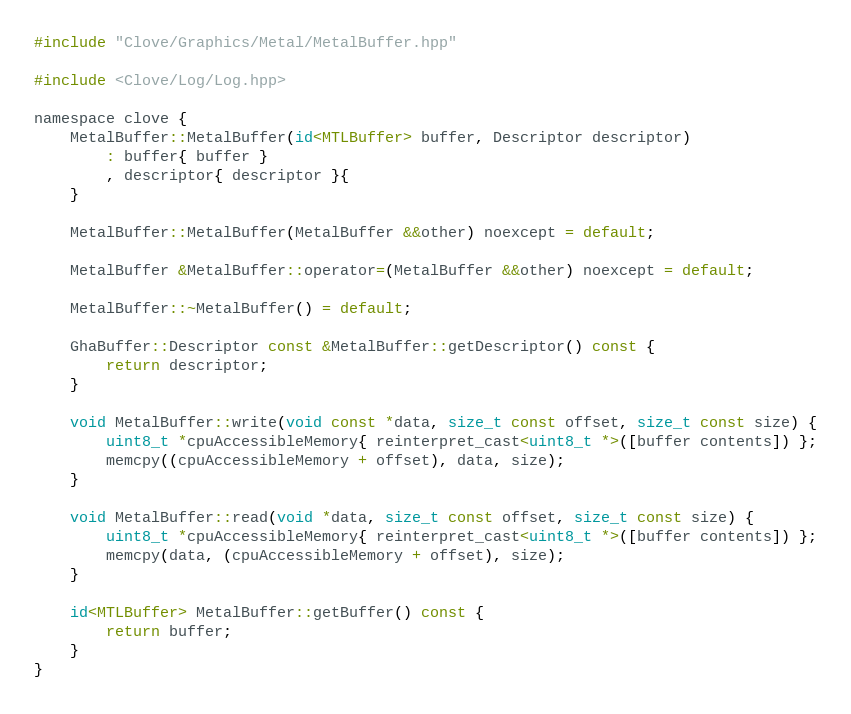<code> <loc_0><loc_0><loc_500><loc_500><_ObjectiveC_>#include "Clove/Graphics/Metal/MetalBuffer.hpp"

#include <Clove/Log/Log.hpp>

namespace clove {
	MetalBuffer::MetalBuffer(id<MTLBuffer> buffer, Descriptor descriptor)
		: buffer{ buffer }
		, descriptor{ descriptor }{
	}

	MetalBuffer::MetalBuffer(MetalBuffer &&other) noexcept = default;

	MetalBuffer &MetalBuffer::operator=(MetalBuffer &&other) noexcept = default;

	MetalBuffer::~MetalBuffer() = default;

	GhaBuffer::Descriptor const &MetalBuffer::getDescriptor() const {
        return descriptor;
    }

	void MetalBuffer::write(void const *data, size_t const offset, size_t const size) {
		uint8_t *cpuAccessibleMemory{ reinterpret_cast<uint8_t *>([buffer contents]) };
		memcpy((cpuAccessibleMemory + offset), data, size);
	}

	void MetalBuffer::read(void *data, size_t const offset, size_t const size) {
		uint8_t *cpuAccessibleMemory{ reinterpret_cast<uint8_t *>([buffer contents]) };
		memcpy(data, (cpuAccessibleMemory + offset), size);
	}

	id<MTLBuffer> MetalBuffer::getBuffer() const {
		return buffer;
	}
}
</code> 